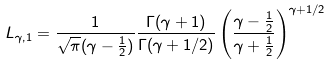Convert formula to latex. <formula><loc_0><loc_0><loc_500><loc_500>L _ { \gamma , 1 } = \frac { 1 } { \sqrt { \pi } ( \gamma - \frac { 1 } { 2 } ) } \frac { \Gamma ( \gamma + 1 ) } { \Gamma ( \gamma + 1 / 2 ) } \left ( \frac { \gamma - \frac { 1 } { 2 } } { \gamma + \frac { 1 } { 2 } } \right ) ^ { \gamma + 1 / 2 }</formula> 